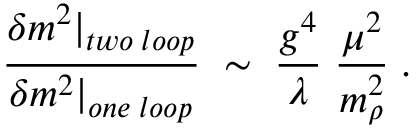Convert formula to latex. <formula><loc_0><loc_0><loc_500><loc_500>\frac { \delta m ^ { 2 } | _ { t w o \, l o o p } } { \delta m ^ { 2 } | _ { o n e \, l o o p } } \, \sim \, \frac { g ^ { 4 } } { \lambda } \, \frac { \mu ^ { 2 } } { m _ { \rho } ^ { 2 } } \, .</formula> 